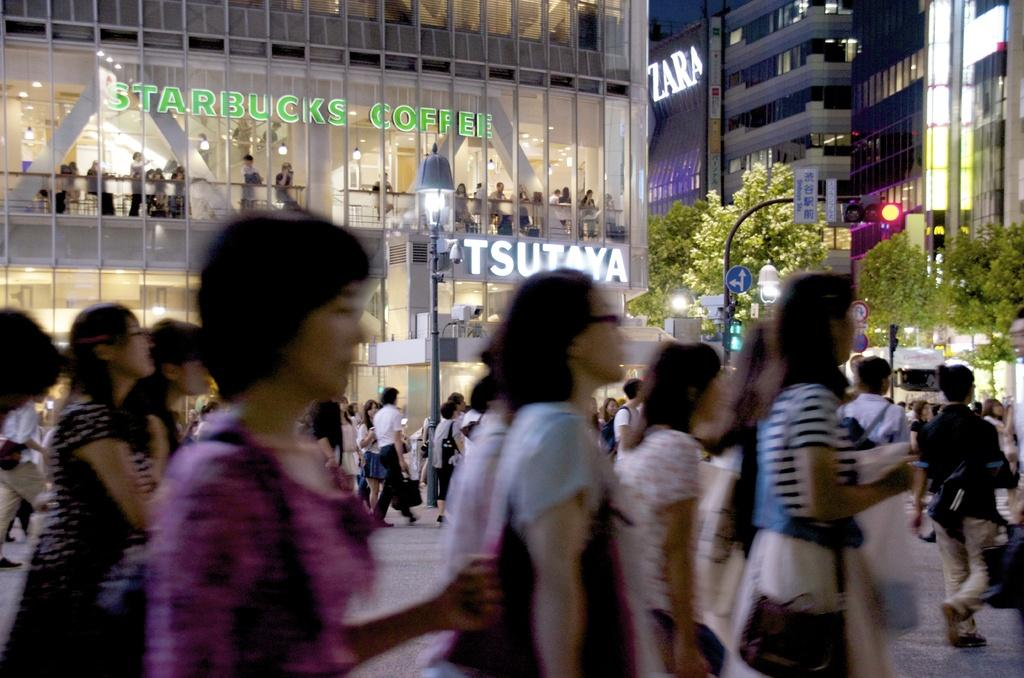What are the people in the image doing? There is a group of people walking in the image. What can be seen controlling the traffic in the image? There is a traffic signal visible in the image. What type of vegetation is present in the image? There are trees with green color in the image. What structures provide light in the image? There are light poles in the image. What is the color of the building in the image? There is a building with a white color in the image. What type of gate can be seen in the image? There is no gate present in the image. How many bananas are hanging from the trees in the image? There are no bananas present in the image; the trees have green leaves. 